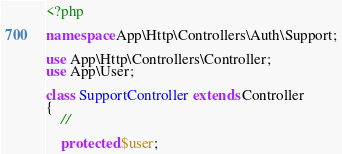<code> <loc_0><loc_0><loc_500><loc_500><_PHP_><?php

namespace App\Http\Controllers\Auth\Support;

use App\Http\Controllers\Controller;
use App\User;

class SupportController extends Controller
{
    //

    protected $user;
</code> 